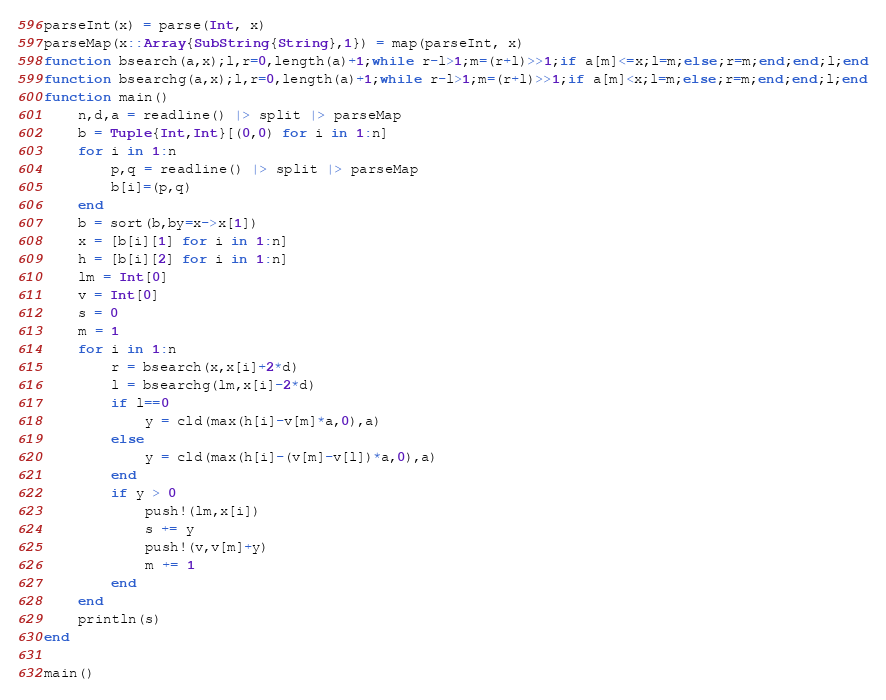Convert code to text. <code><loc_0><loc_0><loc_500><loc_500><_Julia_>parseInt(x) = parse(Int, x)
parseMap(x::Array{SubString{String},1}) = map(parseInt, x)
function bsearch(a,x);l,r=0,length(a)+1;while r-l>1;m=(r+l)>>1;if a[m]<=x;l=m;else;r=m;end;end;l;end
function bsearchg(a,x);l,r=0,length(a)+1;while r-l>1;m=(r+l)>>1;if a[m]<x;l=m;else;r=m;end;end;l;end
function main()
	n,d,a = readline() |> split |> parseMap
	b = Tuple{Int,Int}[(0,0) for i in 1:n]
	for i in 1:n
		p,q = readline() |> split |> parseMap
		b[i]=(p,q)
	end
	b = sort(b,by=x->x[1])
	x = [b[i][1] for i in 1:n]
	h = [b[i][2] for i in 1:n]
	lm = Int[0]
	v = Int[0]
	s = 0
	m = 1
	for i in 1:n
		r = bsearch(x,x[i]+2*d)
		l = bsearchg(lm,x[i]-2*d)
		if l==0
			y = cld(max(h[i]-v[m]*a,0),a)
		else
			y = cld(max(h[i]-(v[m]-v[l])*a,0),a)
		end
		if y > 0
			push!(lm,x[i])
			s += y
			push!(v,v[m]+y)
			m += 1
		end
	end
	println(s)
end

main()</code> 